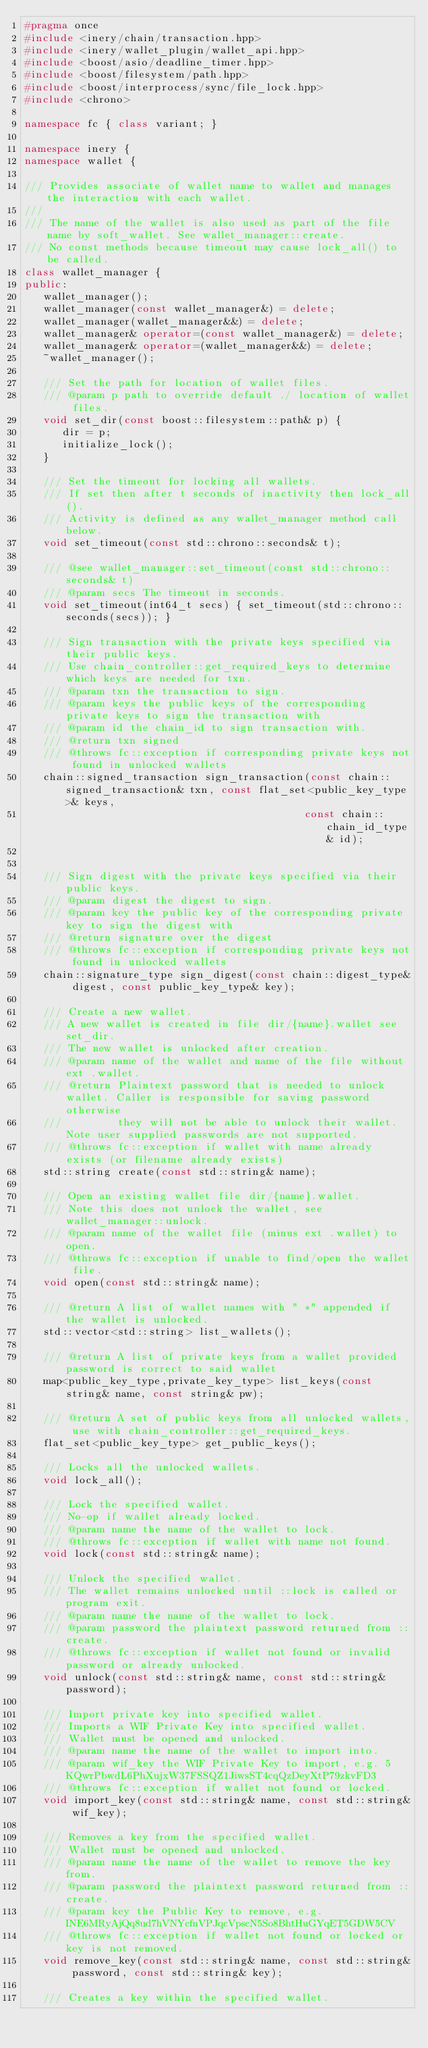Convert code to text. <code><loc_0><loc_0><loc_500><loc_500><_C++_>#pragma once
#include <inery/chain/transaction.hpp>
#include <inery/wallet_plugin/wallet_api.hpp>
#include <boost/asio/deadline_timer.hpp>
#include <boost/filesystem/path.hpp>
#include <boost/interprocess/sync/file_lock.hpp>
#include <chrono>

namespace fc { class variant; }

namespace inery {
namespace wallet {

/// Provides associate of wallet name to wallet and manages the interaction with each wallet.
///
/// The name of the wallet is also used as part of the file name by soft_wallet. See wallet_manager::create.
/// No const methods because timeout may cause lock_all() to be called.
class wallet_manager {
public:
   wallet_manager();
   wallet_manager(const wallet_manager&) = delete;
   wallet_manager(wallet_manager&&) = delete;
   wallet_manager& operator=(const wallet_manager&) = delete;
   wallet_manager& operator=(wallet_manager&&) = delete;
   ~wallet_manager();

   /// Set the path for location of wallet files.
   /// @param p path to override default ./ location of wallet files.
   void set_dir(const boost::filesystem::path& p) {
      dir = p;
      initialize_lock();
   }

   /// Set the timeout for locking all wallets.
   /// If set then after t seconds of inactivity then lock_all().
   /// Activity is defined as any wallet_manager method call below.
   void set_timeout(const std::chrono::seconds& t);

   /// @see wallet_manager::set_timeout(const std::chrono::seconds& t)
   /// @param secs The timeout in seconds.
   void set_timeout(int64_t secs) { set_timeout(std::chrono::seconds(secs)); }
      
   /// Sign transaction with the private keys specified via their public keys.
   /// Use chain_controller::get_required_keys to determine which keys are needed for txn.
   /// @param txn the transaction to sign.
   /// @param keys the public keys of the corresponding private keys to sign the transaction with
   /// @param id the chain_id to sign transaction with.
   /// @return txn signed
   /// @throws fc::exception if corresponding private keys not found in unlocked wallets
   chain::signed_transaction sign_transaction(const chain::signed_transaction& txn, const flat_set<public_key_type>& keys,
                                             const chain::chain_id_type& id);


   /// Sign digest with the private keys specified via their public keys.
   /// @param digest the digest to sign.
   /// @param key the public key of the corresponding private key to sign the digest with
   /// @return signature over the digest
   /// @throws fc::exception if corresponding private keys not found in unlocked wallets
   chain::signature_type sign_digest(const chain::digest_type& digest, const public_key_type& key);

   /// Create a new wallet.
   /// A new wallet is created in file dir/{name}.wallet see set_dir.
   /// The new wallet is unlocked after creation.
   /// @param name of the wallet and name of the file without ext .wallet.
   /// @return Plaintext password that is needed to unlock wallet. Caller is responsible for saving password otherwise
   ///         they will not be able to unlock their wallet. Note user supplied passwords are not supported.
   /// @throws fc::exception if wallet with name already exists (or filename already exists)
   std::string create(const std::string& name);

   /// Open an existing wallet file dir/{name}.wallet.
   /// Note this does not unlock the wallet, see wallet_manager::unlock.
   /// @param name of the wallet file (minus ext .wallet) to open.
   /// @throws fc::exception if unable to find/open the wallet file.
   void open(const std::string& name);

   /// @return A list of wallet names with " *" appended if the wallet is unlocked.
   std::vector<std::string> list_wallets();

   /// @return A list of private keys from a wallet provided password is correct to said wallet
   map<public_key_type,private_key_type> list_keys(const string& name, const string& pw);

   /// @return A set of public keys from all unlocked wallets, use with chain_controller::get_required_keys.
   flat_set<public_key_type> get_public_keys();

   /// Locks all the unlocked wallets.
   void lock_all();

   /// Lock the specified wallet.
   /// No-op if wallet already locked.
   /// @param name the name of the wallet to lock.
   /// @throws fc::exception if wallet with name not found.
   void lock(const std::string& name);

   /// Unlock the specified wallet.
   /// The wallet remains unlocked until ::lock is called or program exit.
   /// @param name the name of the wallet to lock.
   /// @param password the plaintext password returned from ::create.
   /// @throws fc::exception if wallet not found or invalid password or already unlocked.
   void unlock(const std::string& name, const std::string& password);

   /// Import private key into specified wallet.
   /// Imports a WIF Private Key into specified wallet.
   /// Wallet must be opened and unlocked.
   /// @param name the name of the wallet to import into.
   /// @param wif_key the WIF Private Key to import, e.g. 5KQwrPbwdL6PhXujxW37FSSQZ1JiwsST4cqQzDeyXtP79zkvFD3
   /// @throws fc::exception if wallet not found or locked.
   void import_key(const std::string& name, const std::string& wif_key);

   /// Removes a key from the specified wallet.
   /// Wallet must be opened and unlocked.
   /// @param name the name of the wallet to remove the key from.
   /// @param password the plaintext password returned from ::create.
   /// @param key the Public Key to remove, e.g. INE6MRyAjQq8ud7hVNYcfnVPJqcVpscN5So8BhtHuGYqET5GDW5CV
   /// @throws fc::exception if wallet not found or locked or key is not removed.
   void remove_key(const std::string& name, const std::string& password, const std::string& key);

   /// Creates a key within the specified wallet.</code> 